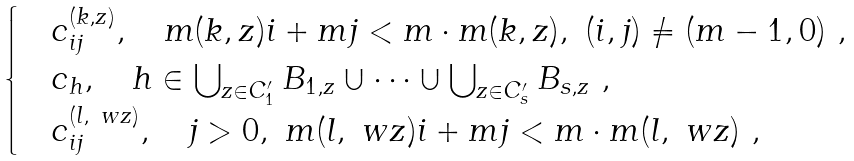<formula> <loc_0><loc_0><loc_500><loc_500>\begin{cases} & c ^ { ( k , z ) } _ { i j } , \quad m ( k , z ) i + m j < m \cdot m ( k , z ) , \ ( i , j ) \ne ( m - 1 , 0 ) \ , \\ & c _ { h } , \quad h \in \bigcup _ { z \in C ^ { \prime } _ { 1 } } B _ { 1 , z } \cup \dots \cup \bigcup _ { z \in C ^ { \prime } _ { s } } B _ { s , z } \ , \\ & c ^ { ( l , \ w z ) } _ { i j } , \quad j > 0 , \ m ( l , \ w z ) i + m j < m \cdot m ( l , \ w z ) \ , \end{cases}</formula> 